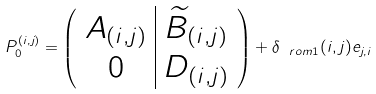<formula> <loc_0><loc_0><loc_500><loc_500>P _ { 0 } ^ { ( i , j ) } = \left ( \begin{array} { c | c } A _ { ( i , j ) } & \widetilde { B } _ { ( i , j ) } \\ 0 & D _ { ( i , j ) } \end{array} \right ) + \delta _ { \ r o m { 1 } } ( i , j ) e _ { j , i }</formula> 